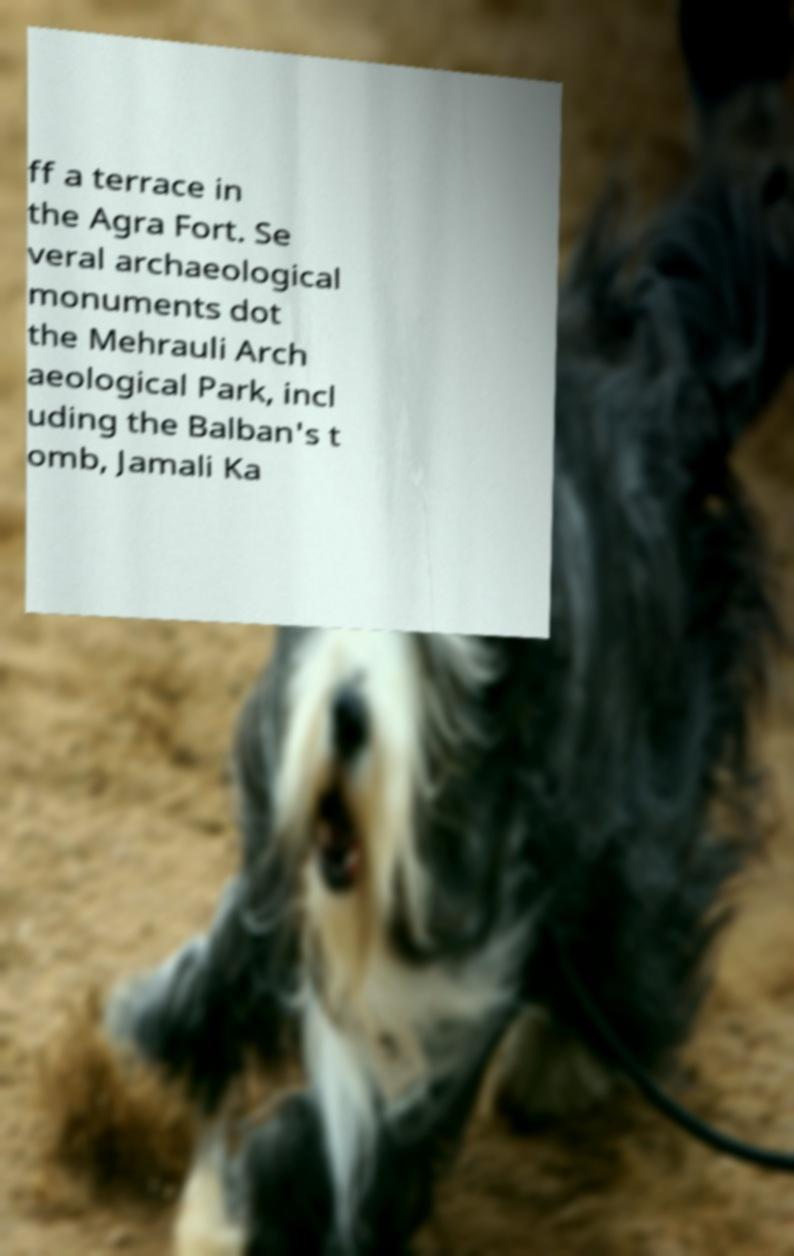Can you read and provide the text displayed in the image?This photo seems to have some interesting text. Can you extract and type it out for me? ff a terrace in the Agra Fort. Se veral archaeological monuments dot the Mehrauli Arch aeological Park, incl uding the Balban's t omb, Jamali Ka 